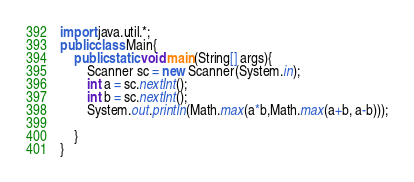Convert code to text. <code><loc_0><loc_0><loc_500><loc_500><_Java_>import java.util.*;
public class Main{
	public static void main(String[] args){
    	Scanner sc = new Scanner(System.in);
      	int a = sc.nextInt();
		int b = sc.nextInt();
      	System.out.println(Math.max(a*b,Math.max(a+b, a-b)));
      	
    }
}</code> 